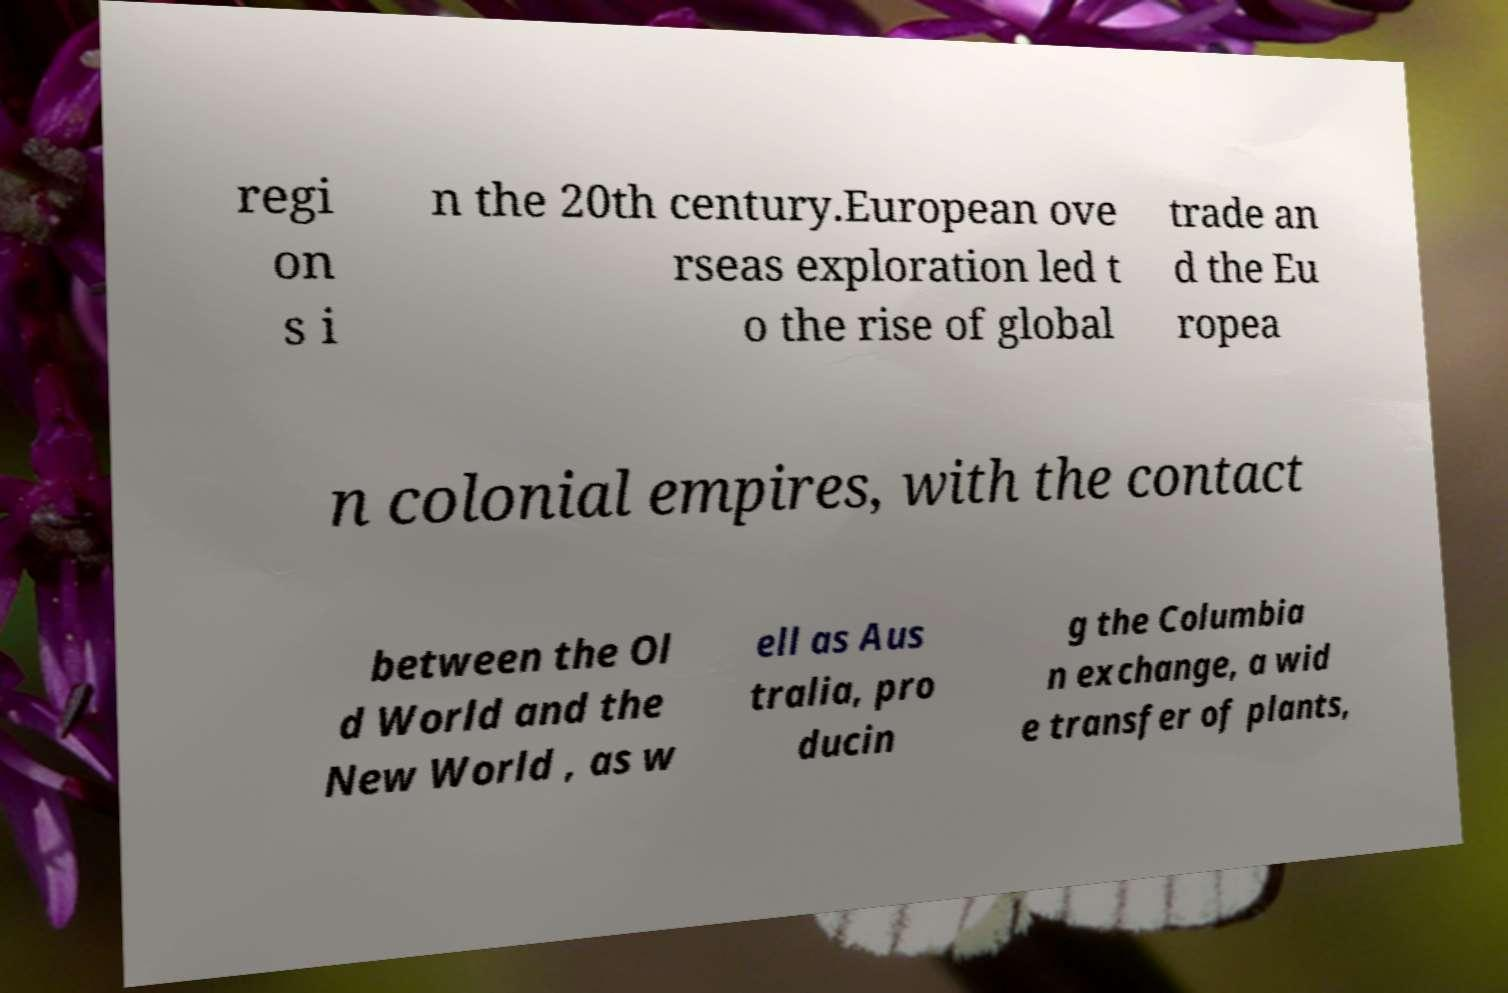Can you accurately transcribe the text from the provided image for me? regi on s i n the 20th century.European ove rseas exploration led t o the rise of global trade an d the Eu ropea n colonial empires, with the contact between the Ol d World and the New World , as w ell as Aus tralia, pro ducin g the Columbia n exchange, a wid e transfer of plants, 